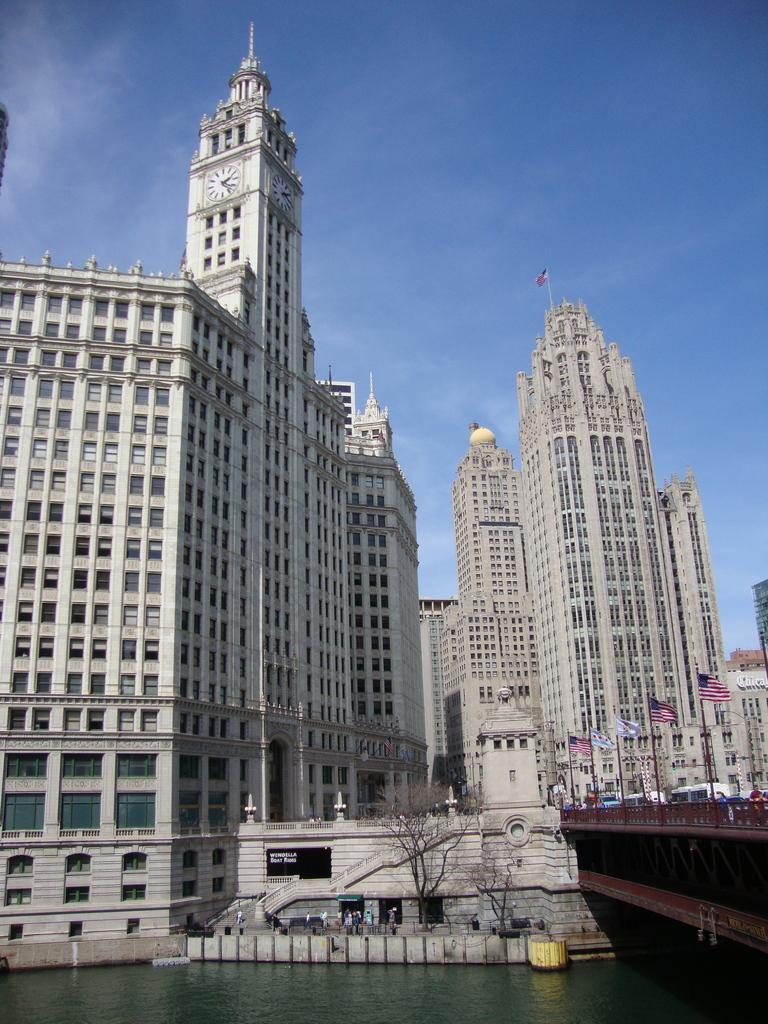What color is the sky in the image? The sky is blue in the image. What structures can be seen in the image? There are buildings in the image. What is placed in front of the buildings? There are flags and bare trees in front of the buildings. What is the landscape feature in front of the buildings? There is water in front of the buildings. How does one cross the water in the image? There is a bridge above the water in the image. What type of soda is being advertised on the basketball court in the image? There is no basketball court or soda advertisement present in the image. What is the result of the division between the two teams in the image? There are no teams or division present in the image. 